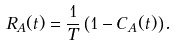<formula> <loc_0><loc_0><loc_500><loc_500>R _ { A } ( t ) = \frac { 1 } { T } \left ( 1 - C _ { A } ( t ) \right ) .</formula> 